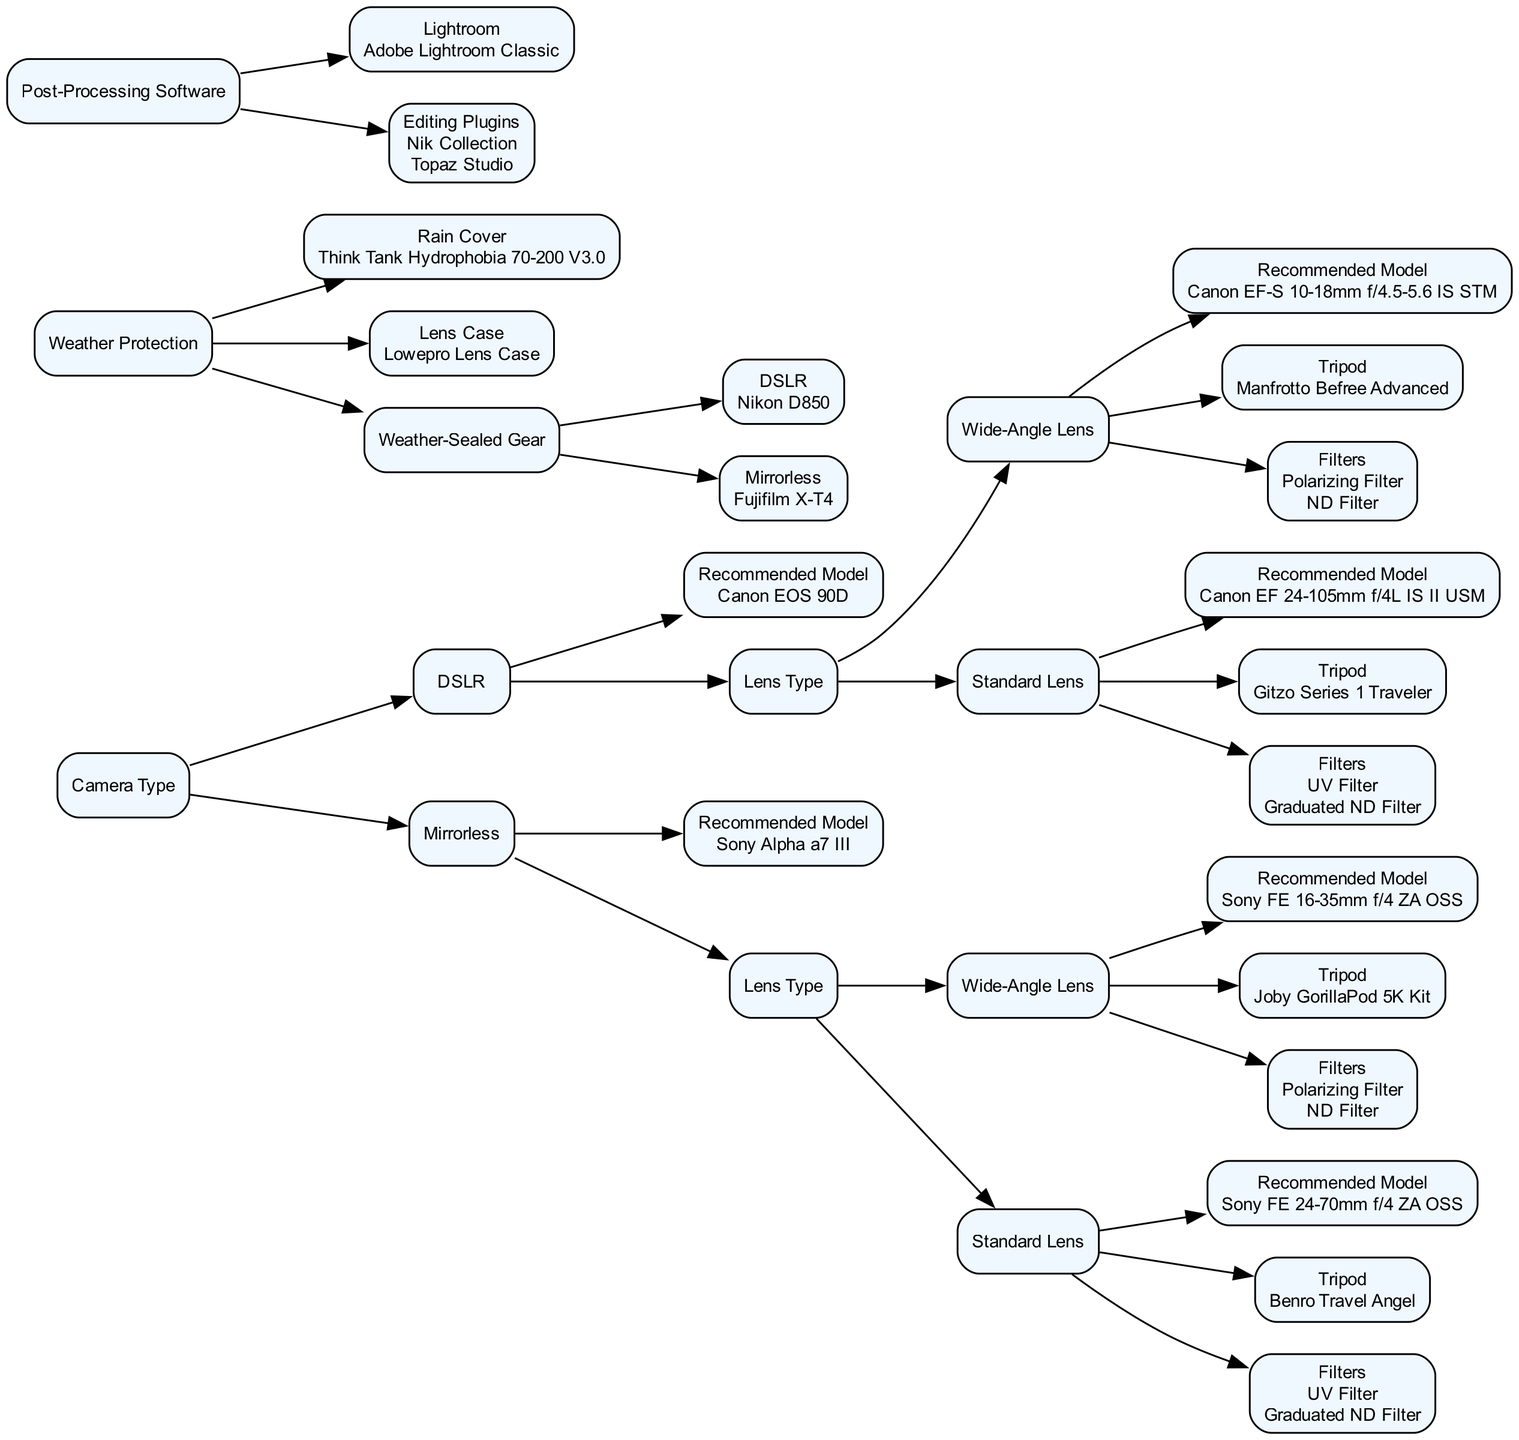What is the recommended DSLR model for landscape photography? The diagram indicates that the recommended DSLR model is Canon EOS 90D, found under the "Camera Type" category for DSLRs.
Answer: Canon EOS 90D Which lens type is suggested for the Canon EOS 90D? Under the "Lens Type" category for the Canon EOS 90D, both "Wide-Angle Lens" and "Standard Lens" are mentioned, indicating that both types are suitable.
Answer: Wide-Angle Lens and Standard Lens What filters are recommended when using a wide-angle lens with the Sony Alpha a7 III? The diagram shows that both a Polarizing Filter and an ND Filter are recommended for the wide-angle lens associated with the Sony Alpha a7 III.
Answer: Polarizing Filter, ND Filter What tripod should be used with the Canon EF-S 10-18mm f/4.5-5.6 IS STM lens? The recommended tripod for the Canon EF-S 10-18mm lens, positioned under the DSLR category with a wide-angle lens, is the Manfrotto Befree Advanced.
Answer: Manfrotto Befree Advanced How many types of camera types are identified in the decision tree? The decision tree categorizes camera types into two clear categories: DSLR and Mirrorless. Thus, the total number of camera types is two.
Answer: 2 What piece of weather protection gear is suggested in the diagram? The diagram specifies the Think Tank Hydrophobia 70-200 V3.0 as a rain cover for weather protection, indicating it as a recommended item for photographers.
Answer: Think Tank Hydrophobia 70-200 V3.0 Which software is recommended for post-processing? The recommended software for post-processing in the diagram is Adobe Lightroom Classic, listed under "Post-Processing Software."
Answer: Adobe Lightroom Classic What is the recommended lens case in the decision tree? The Lowepro Lens Case is mentioned in the diagram as the recommended lens case for protecting lenses during landscape photography.
Answer: Lowepro Lens Case Which camera model is specified as weather-sealed for Mirrorless type? According to the diagram under the "Weather Protection" category, the weather-sealed gear for the Mirrorless type is the Fujifilm X-T4.
Answer: Fujifilm X-T4 